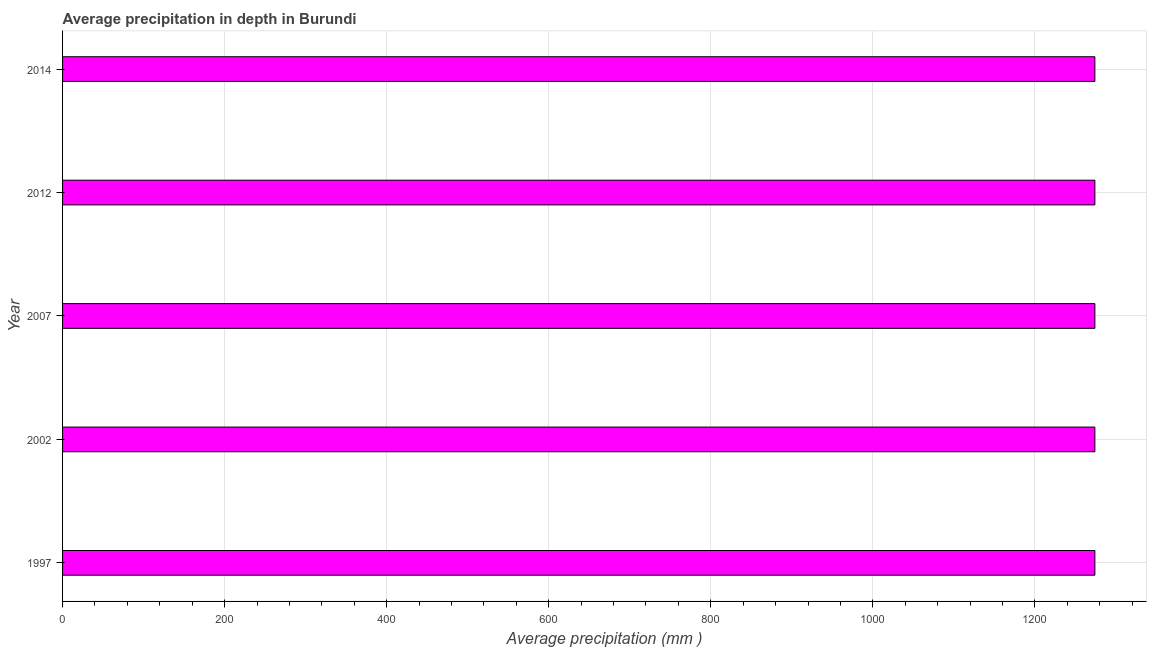What is the title of the graph?
Offer a very short reply. Average precipitation in depth in Burundi. What is the label or title of the X-axis?
Provide a short and direct response. Average precipitation (mm ). What is the label or title of the Y-axis?
Keep it short and to the point. Year. What is the average precipitation in depth in 2014?
Offer a very short reply. 1274. Across all years, what is the maximum average precipitation in depth?
Offer a terse response. 1274. Across all years, what is the minimum average precipitation in depth?
Your answer should be very brief. 1274. What is the sum of the average precipitation in depth?
Keep it short and to the point. 6370. What is the difference between the average precipitation in depth in 2002 and 2012?
Offer a very short reply. 0. What is the average average precipitation in depth per year?
Your answer should be compact. 1274. What is the median average precipitation in depth?
Your answer should be very brief. 1274. Do a majority of the years between 2014 and 2007 (inclusive) have average precipitation in depth greater than 40 mm?
Give a very brief answer. Yes. Is the average precipitation in depth in 1997 less than that in 2007?
Your response must be concise. No. Is the sum of the average precipitation in depth in 2002 and 2014 greater than the maximum average precipitation in depth across all years?
Provide a succinct answer. Yes. In how many years, is the average precipitation in depth greater than the average average precipitation in depth taken over all years?
Provide a succinct answer. 0. What is the difference between two consecutive major ticks on the X-axis?
Provide a short and direct response. 200. What is the Average precipitation (mm ) of 1997?
Your answer should be compact. 1274. What is the Average precipitation (mm ) of 2002?
Your answer should be compact. 1274. What is the Average precipitation (mm ) of 2007?
Offer a very short reply. 1274. What is the Average precipitation (mm ) in 2012?
Provide a short and direct response. 1274. What is the Average precipitation (mm ) in 2014?
Offer a very short reply. 1274. What is the difference between the Average precipitation (mm ) in 1997 and 2014?
Provide a succinct answer. 0. What is the difference between the Average precipitation (mm ) in 2002 and 2012?
Your answer should be very brief. 0. What is the difference between the Average precipitation (mm ) in 2007 and 2012?
Offer a terse response. 0. What is the difference between the Average precipitation (mm ) in 2007 and 2014?
Give a very brief answer. 0. What is the difference between the Average precipitation (mm ) in 2012 and 2014?
Your answer should be compact. 0. What is the ratio of the Average precipitation (mm ) in 1997 to that in 2012?
Give a very brief answer. 1. What is the ratio of the Average precipitation (mm ) in 2002 to that in 2007?
Ensure brevity in your answer.  1. What is the ratio of the Average precipitation (mm ) in 2002 to that in 2014?
Provide a succinct answer. 1. What is the ratio of the Average precipitation (mm ) in 2007 to that in 2012?
Give a very brief answer. 1. 